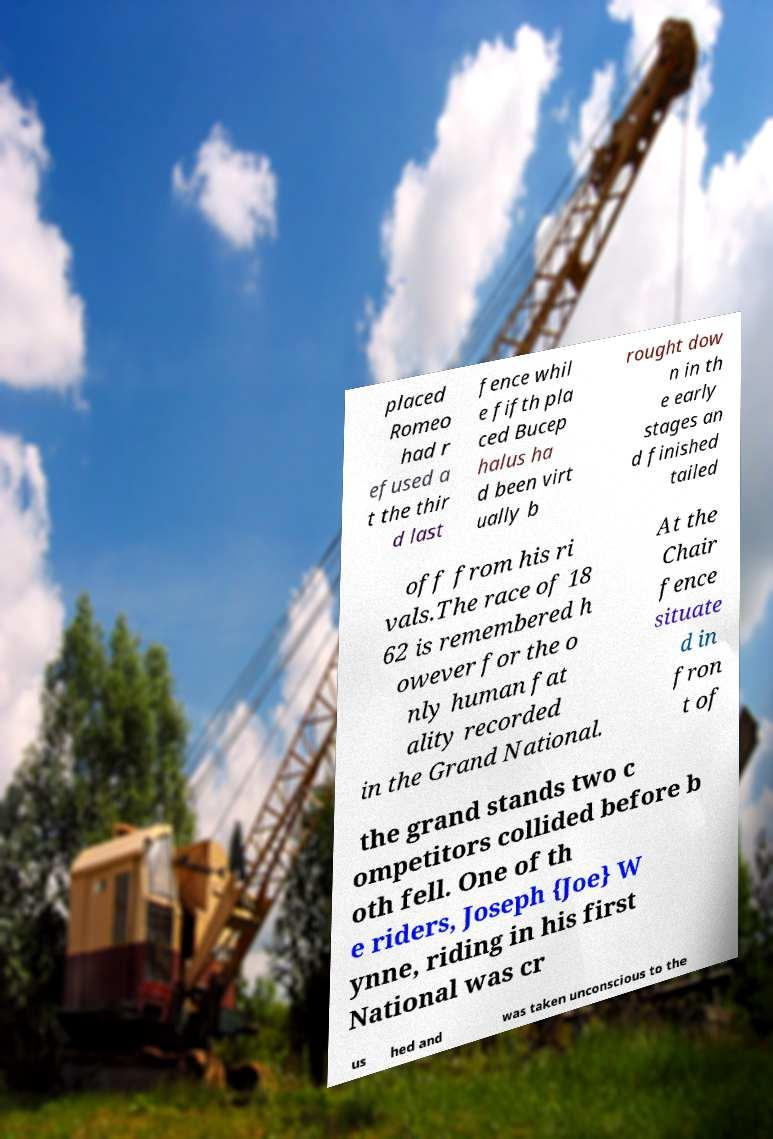What messages or text are displayed in this image? I need them in a readable, typed format. placed Romeo had r efused a t the thir d last fence whil e fifth pla ced Bucep halus ha d been virt ually b rought dow n in th e early stages an d finished tailed off from his ri vals.The race of 18 62 is remembered h owever for the o nly human fat ality recorded in the Grand National. At the Chair fence situate d in fron t of the grand stands two c ompetitors collided before b oth fell. One of th e riders, Joseph {Joe} W ynne, riding in his first National was cr us hed and was taken unconscious to the 